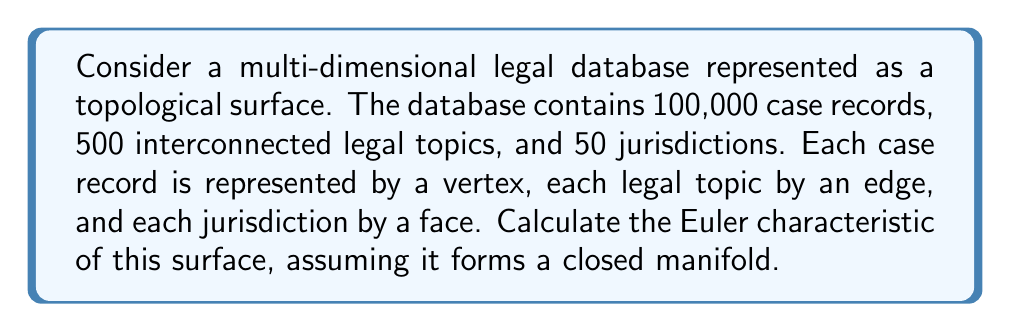Show me your answer to this math problem. To solve this problem, we need to use the Euler characteristic formula for a closed surface:

$$\chi = V - E + F$$

Where:
$\chi$ is the Euler characteristic
$V$ is the number of vertices
$E$ is the number of edges
$F$ is the number of faces

Given information:
- Vertices (case records): $V = 100,000$
- Edges (legal topics): $E = 500$
- Faces (jurisdictions): $F = 50$

Let's substitute these values into the Euler characteristic formula:

$$\chi = 100,000 - 500 + 50$$

Simplifying:
$$\chi = 99,550$$

It's worth noting that this unusually large Euler characteristic suggests a highly complex and disconnected surface. In a real-world scenario, we would expect more connections between legal topics, potentially resulting in a more interconnected surface with a different Euler characteristic.

For a legal scholar, this result might indicate the need for better integration and cross-referencing within the legal database to improve its utility and coherence across jurisdictions and topics.
Answer: $$\chi = 99,550$$ 